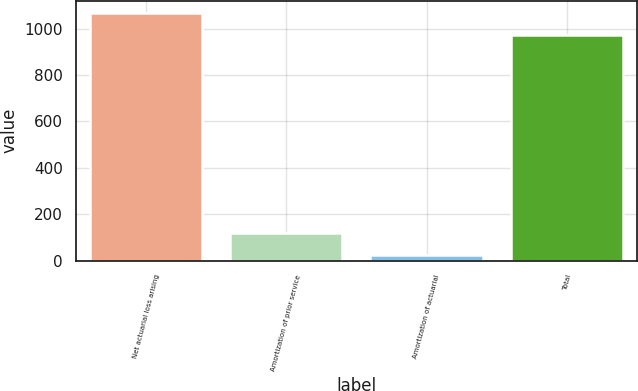Convert chart to OTSL. <chart><loc_0><loc_0><loc_500><loc_500><bar_chart><fcel>Net actuarial loss arising<fcel>Amortization of prior service<fcel>Amortization of actuarial<fcel>Total<nl><fcel>1067.3<fcel>118.3<fcel>23<fcel>972<nl></chart> 